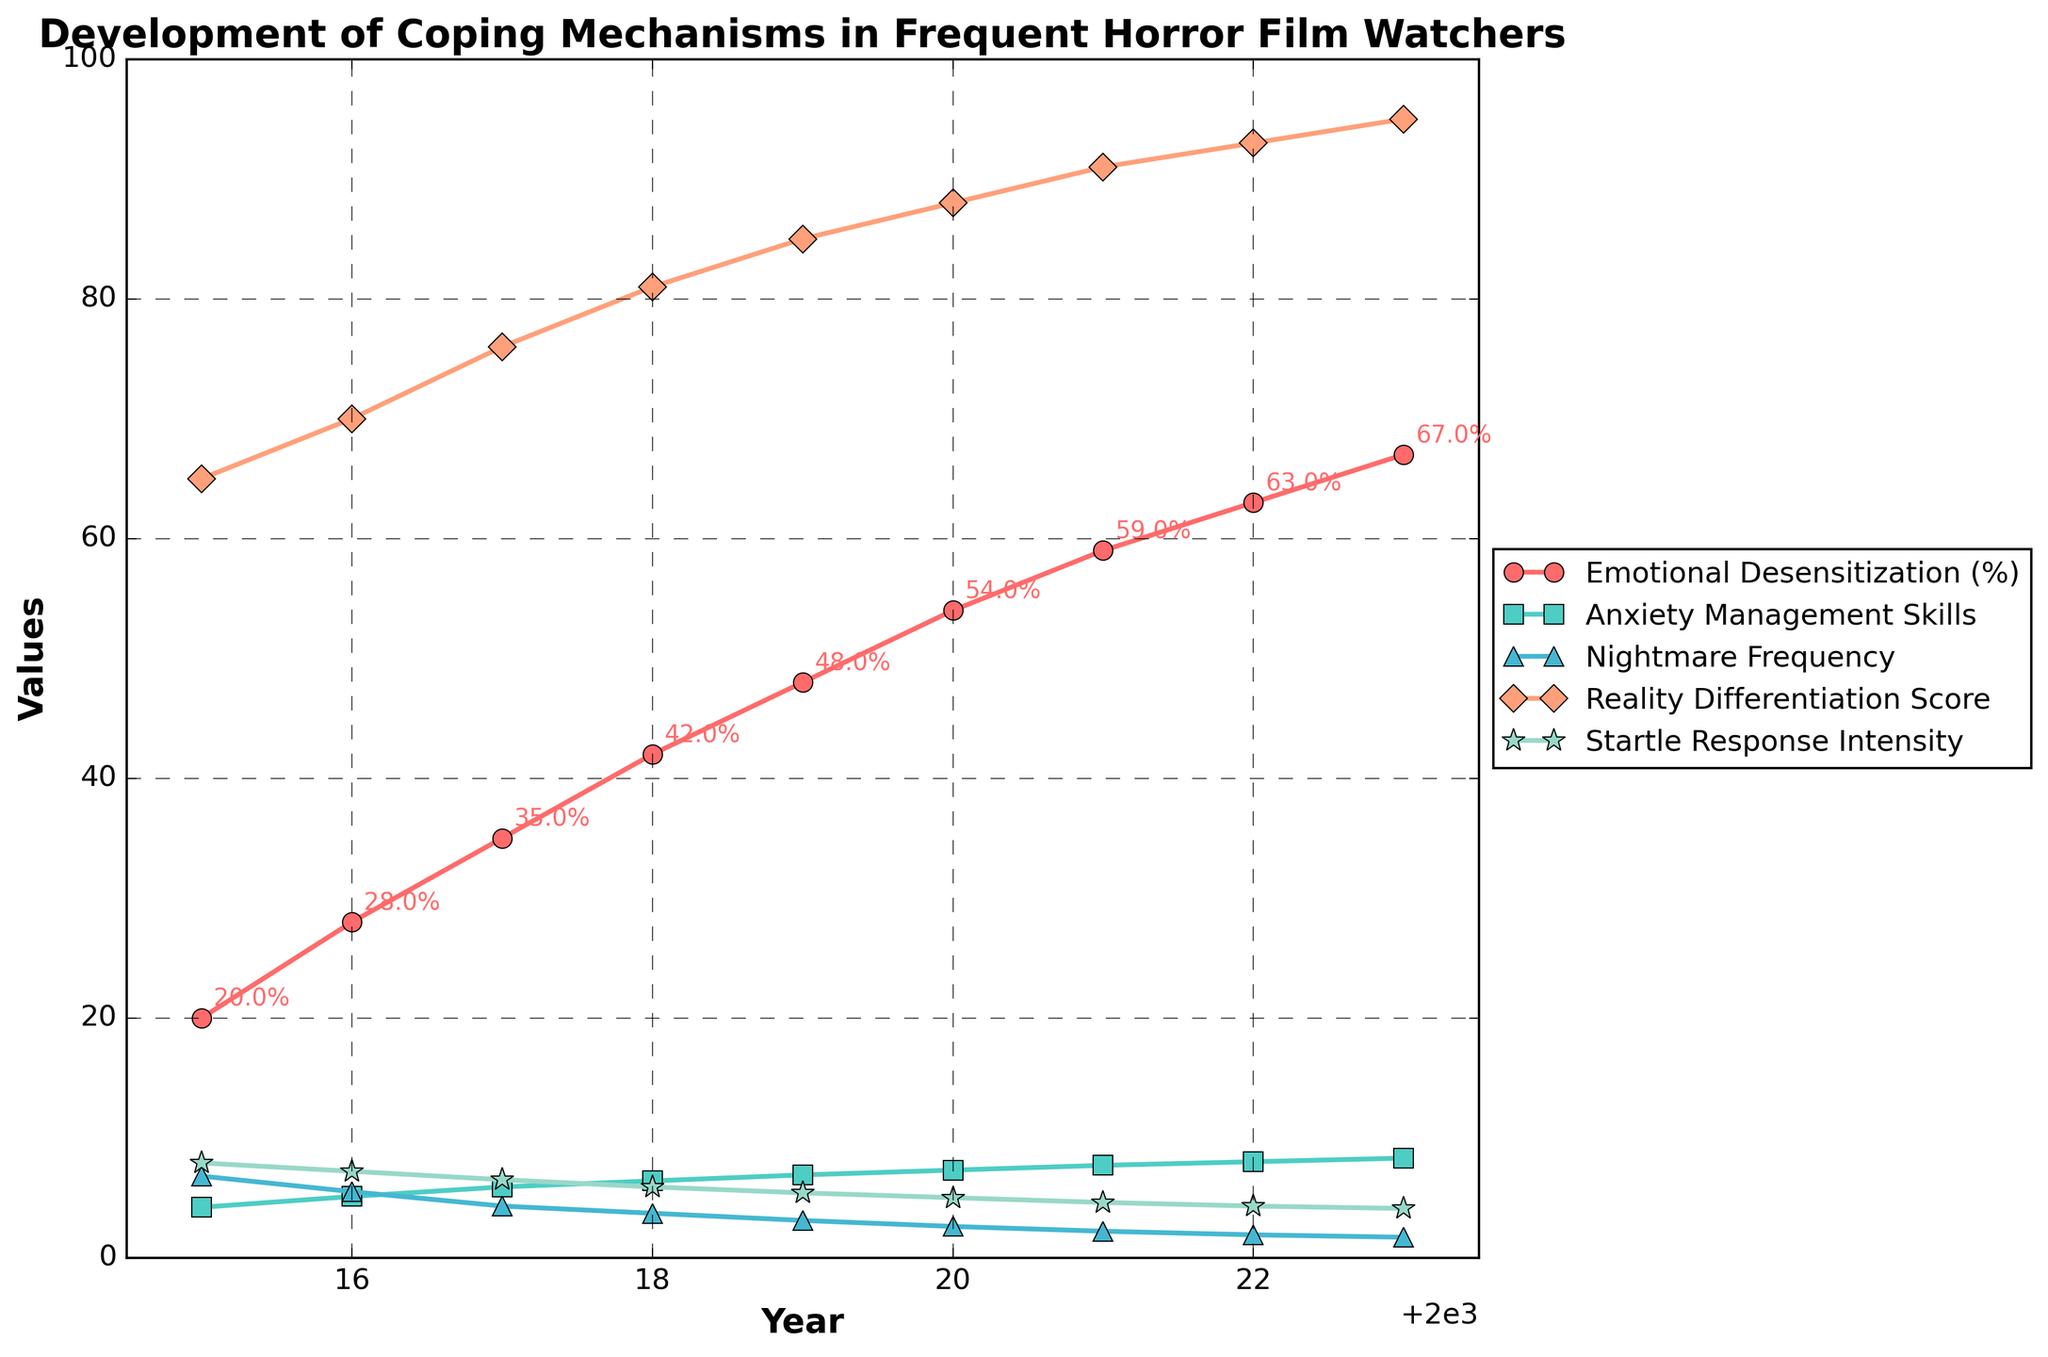Which year showed the highest Emotional Desensitization percentage? Look at the line representing Emotional Desensitization (%). It reaches its highest value in 2023.
Answer: 2023 By how much did Anxiety Management Skills increase from 2015 to 2023? In 2015, Anxiety Management Skills were at 4.2, and in 2023, they were at 8.3. The increase is 8.3 - 4.2 = 4.1.
Answer: 4.1 What is the average Reality Differentiation Score across the years? Sum up the scores from each year and divide by the number of years. Sum: 65 + 70 + 76 + 81 + 85 + 88 + 91 + 93 + 95 = 744. Number of years = 9. Average: 744 / 9 ≈ 82.67.
Answer: 82.67 Which metric has the most significant change over the years? Compare the changes from 2015 to 2023 for each metric. Emotional Desensitization (%) changes from 20% to 67% (47%), Anxiety Management Skills from 4.2 to 8.3 (4.1), Nightmare Frequency from 6.8 to 1.7 (5.1), Reality Differentiation Score from 65 to 95 (30), and Startle Response Intensity from 7.9 to 4.1 (3.8). The most significant change is in Emotional Desensitization (%), changing by 47%.
Answer: Emotional Desensitization (%) How does the Nightmare Frequency trend compare to the Anxiety Management Skills trend? Nightmare Frequency consistently decreases from 6.8 to 1.7, while Anxiety Management Skills steadily increase from 4.2 to 8.3 throughout the years. Essentially, as Nightmare Frequency decreases, Anxiety Management Skills increase.
Answer: Inverse relationship What year did the Reality Differentiation Score first surpass 80? Observe the Reality Differentiation Score line, which surpasses 80 for the first time in 2018, with a value of 81.
Answer: 2018 How much did Startle Response Intensity decrease from 2015 to 2023? In 2015, it was 7.9, and in 2023, it was 4.1. The decrease is 7.9 - 4.1 = 3.8.
Answer: 3.8 Which year had the largest decrease in Nightmare Frequency compared to the previous year? Calculate the differences year-to-year. The largest decrease is between 2017 (4.3) and 2018 (3.7), with a difference of 4.3 - 3.7 = 0.6.
Answer: 2017 to 2018 What is the cumulative increase in Emotional Desensitization (%), Anxiety Management Skills (1-10), and Reality Differentiation Score (1-100) from 2015 to 2023? Calculate the increases: Emotional Desensitization (%) increases by 47 (67 - 20), Anxiety Management Skills by 4.1 (8.3 - 4.2), and Reality Differentiation Score by 30 (95 - 65). Sum of increases: 47 + 4.1 + 30 = 81.1.
Answer: 81.1 